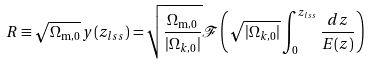<formula> <loc_0><loc_0><loc_500><loc_500>R \equiv \sqrt { \Omega _ { \text {m} , 0 } } \, y ( z _ { l s s } ) = \sqrt { \frac { \Omega _ { \text {m} , 0 } } { | \Omega _ { k , 0 } | } } \mathcal { F } \left ( \sqrt { | \Omega _ { k , 0 } | } \int _ { 0 } ^ { z _ { l s s } } \frac { d z } { E ( z ) } \right )</formula> 